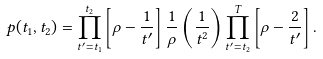<formula> <loc_0><loc_0><loc_500><loc_500>p ( t _ { 1 } , t _ { 2 } ) = \prod _ { t ^ { \prime } = t _ { 1 } } ^ { t _ { 2 } } \left [ \rho - \frac { 1 } { t ^ { \prime } } \right ] \frac { 1 } { \rho } \left ( \frac { 1 } { t ^ { 2 } } \right ) \prod _ { t ^ { \prime } = t _ { 2 } } ^ { T } \left [ \rho - \frac { 2 } { t ^ { \prime } } \right ] .</formula> 